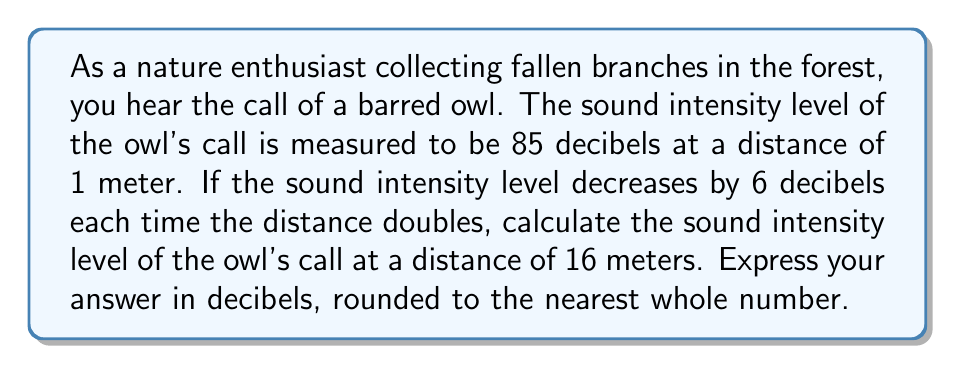Can you answer this question? To solve this problem, we'll use the properties of logarithms and the relationship between distance and sound intensity level.

1) First, let's recall that the sound intensity level (SIL) is measured in decibels and is related to the sound intensity (I) by the following equation:

   $$ SIL = 10 \log_{10}\left(\frac{I}{I_0}\right) $$

   where $I_0$ is the reference intensity.

2) We're told that the SIL decreases by 6 decibels each time the distance doubles. This is consistent with the inverse square law for sound intensity, which states that intensity is inversely proportional to the square of the distance.

3) To get from 1 meter to 16 meters, we need to double the distance 4 times:
   1 m → 2 m → 4 m → 8 m → 16 m

4) Each doubling reduces the SIL by 6 decibels, so the total reduction is:

   $$ 4 \times 6 = 24 \text{ decibels} $$

5) The initial SIL at 1 meter is 85 decibels, so the SIL at 16 meters is:

   $$ 85 - 24 = 61 \text{ decibels} $$

Therefore, the sound intensity level of the owl's call at a distance of 16 meters is 61 decibels.
Answer: 61 decibels 